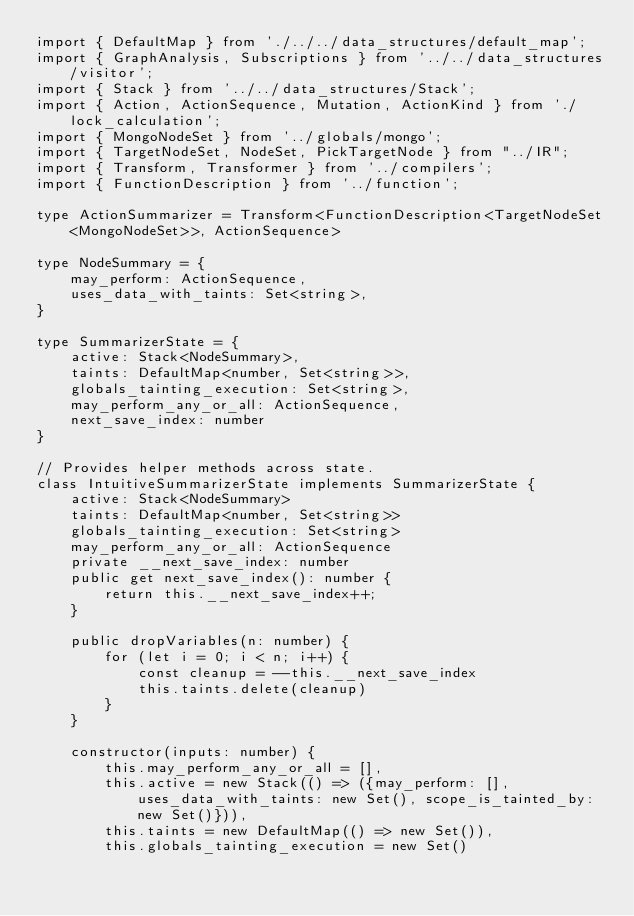Convert code to text. <code><loc_0><loc_0><loc_500><loc_500><_TypeScript_>import { DefaultMap } from './../../data_structures/default_map';
import { GraphAnalysis, Subscriptions } from '../../data_structures/visitor';
import { Stack } from '../../data_structures/Stack';
import { Action, ActionSequence, Mutation, ActionKind } from './lock_calculation';
import { MongoNodeSet } from '../globals/mongo';
import { TargetNodeSet, NodeSet, PickTargetNode } from "../IR";
import { Transform, Transformer } from '../compilers';
import { FunctionDescription } from '../function';

type ActionSummarizer = Transform<FunctionDescription<TargetNodeSet<MongoNodeSet>>, ActionSequence>

type NodeSummary = {
    may_perform: ActionSequence,
    uses_data_with_taints: Set<string>,
}

type SummarizerState = {
    active: Stack<NodeSummary>,
    taints: DefaultMap<number, Set<string>>,
    globals_tainting_execution: Set<string>,
    may_perform_any_or_all: ActionSequence,
    next_save_index: number
}

// Provides helper methods across state.
class IntuitiveSummarizerState implements SummarizerState {
    active: Stack<NodeSummary>
    taints: DefaultMap<number, Set<string>>
    globals_tainting_execution: Set<string>
    may_perform_any_or_all: ActionSequence
    private __next_save_index: number
    public get next_save_index(): number {
        return this.__next_save_index++;
    }
    
    public dropVariables(n: number) {
        for (let i = 0; i < n; i++) {
            const cleanup = --this.__next_save_index
            this.taints.delete(cleanup)    
        }
    }

    constructor(inputs: number) {
        this.may_perform_any_or_all = [], 
        this.active = new Stack(() => ({may_perform: [], uses_data_with_taints: new Set(), scope_is_tainted_by: new Set()})), 
        this.taints = new DefaultMap(() => new Set()),
        this.globals_tainting_execution = new Set()</code> 